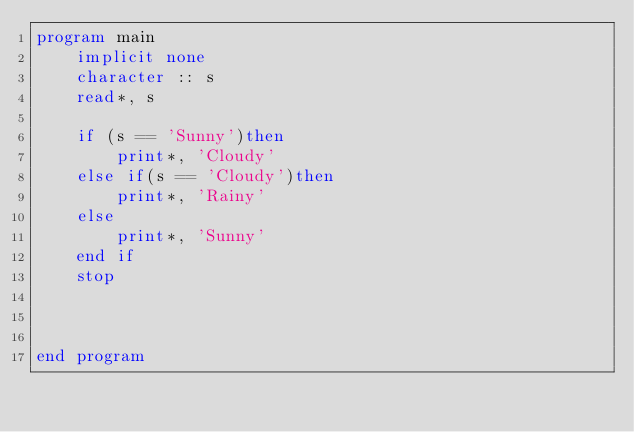<code> <loc_0><loc_0><loc_500><loc_500><_FORTRAN_>program main
    implicit none
    character :: s
    read*, s

    if (s == 'Sunny')then
        print*, 'Cloudy'
    else if(s == 'Cloudy')then
        print*, 'Rainy'
    else
        print*, 'Sunny'
    end if
    stop


    
end program</code> 